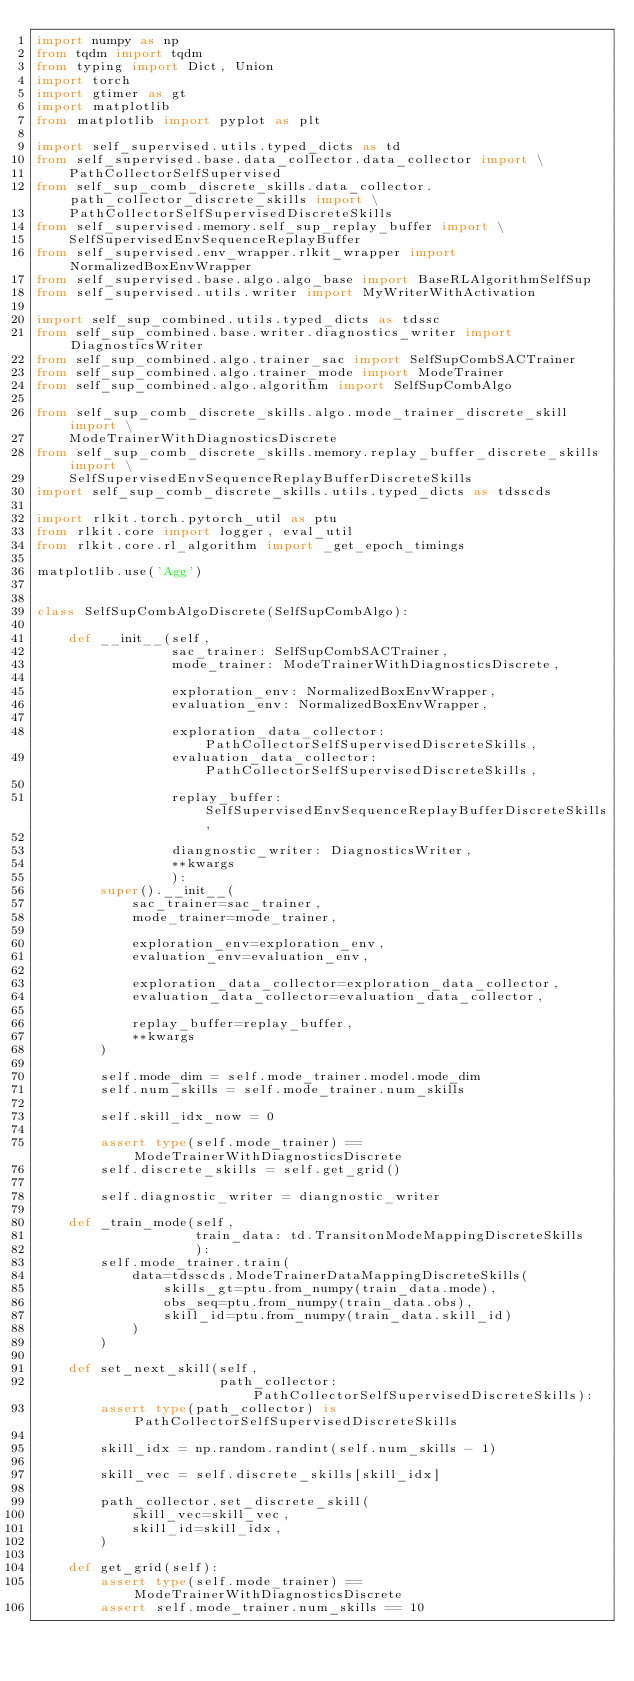<code> <loc_0><loc_0><loc_500><loc_500><_Python_>import numpy as np
from tqdm import tqdm
from typing import Dict, Union
import torch
import gtimer as gt
import matplotlib
from matplotlib import pyplot as plt

import self_supervised.utils.typed_dicts as td
from self_supervised.base.data_collector.data_collector import \
    PathCollectorSelfSupervised
from self_sup_comb_discrete_skills.data_collector.path_collector_discrete_skills import \
    PathCollectorSelfSupervisedDiscreteSkills
from self_supervised.memory.self_sup_replay_buffer import \
    SelfSupervisedEnvSequenceReplayBuffer
from self_supervised.env_wrapper.rlkit_wrapper import NormalizedBoxEnvWrapper
from self_supervised.base.algo.algo_base import BaseRLAlgorithmSelfSup
from self_supervised.utils.writer import MyWriterWithActivation

import self_sup_combined.utils.typed_dicts as tdssc
from self_sup_combined.base.writer.diagnostics_writer import DiagnosticsWriter
from self_sup_combined.algo.trainer_sac import SelfSupCombSACTrainer
from self_sup_combined.algo.trainer_mode import ModeTrainer
from self_sup_combined.algo.algorithm import SelfSupCombAlgo

from self_sup_comb_discrete_skills.algo.mode_trainer_discrete_skill import \
    ModeTrainerWithDiagnosticsDiscrete
from self_sup_comb_discrete_skills.memory.replay_buffer_discrete_skills import \
    SelfSupervisedEnvSequenceReplayBufferDiscreteSkills
import self_sup_comb_discrete_skills.utils.typed_dicts as tdsscds

import rlkit.torch.pytorch_util as ptu
from rlkit.core import logger, eval_util
from rlkit.core.rl_algorithm import _get_epoch_timings

matplotlib.use('Agg')


class SelfSupCombAlgoDiscrete(SelfSupCombAlgo):

    def __init__(self,
                 sac_trainer: SelfSupCombSACTrainer,
                 mode_trainer: ModeTrainerWithDiagnosticsDiscrete,

                 exploration_env: NormalizedBoxEnvWrapper,
                 evaluation_env: NormalizedBoxEnvWrapper,

                 exploration_data_collector: PathCollectorSelfSupervisedDiscreteSkills,
                 evaluation_data_collector: PathCollectorSelfSupervisedDiscreteSkills,

                 replay_buffer: SelfSupervisedEnvSequenceReplayBufferDiscreteSkills,

                 diangnostic_writer: DiagnosticsWriter,
                 **kwargs
                 ):
        super().__init__(
            sac_trainer=sac_trainer,
            mode_trainer=mode_trainer,

            exploration_env=exploration_env,
            evaluation_env=evaluation_env,

            exploration_data_collector=exploration_data_collector,
            evaluation_data_collector=evaluation_data_collector,

            replay_buffer=replay_buffer,
            **kwargs
        )

        self.mode_dim = self.mode_trainer.model.mode_dim
        self.num_skills = self.mode_trainer.num_skills

        self.skill_idx_now = 0

        assert type(self.mode_trainer) == ModeTrainerWithDiagnosticsDiscrete
        self.discrete_skills = self.get_grid()

        self.diagnostic_writer = diangnostic_writer

    def _train_mode(self,
                    train_data: td.TransitonModeMappingDiscreteSkills
                    ):
        self.mode_trainer.train(
            data=tdsscds.ModeTrainerDataMappingDiscreteSkills(
                skills_gt=ptu.from_numpy(train_data.mode),
                obs_seq=ptu.from_numpy(train_data.obs),
                skill_id=ptu.from_numpy(train_data.skill_id)
            )
        )

    def set_next_skill(self,
                       path_collector: PathCollectorSelfSupervisedDiscreteSkills):
        assert type(path_collector) is PathCollectorSelfSupervisedDiscreteSkills

        skill_idx = np.random.randint(self.num_skills - 1)

        skill_vec = self.discrete_skills[skill_idx]

        path_collector.set_discrete_skill(
            skill_vec=skill_vec,
            skill_id=skill_idx,
        )

    def get_grid(self):
        assert type(self.mode_trainer) == ModeTrainerWithDiagnosticsDiscrete
        assert self.mode_trainer.num_skills == 10</code> 